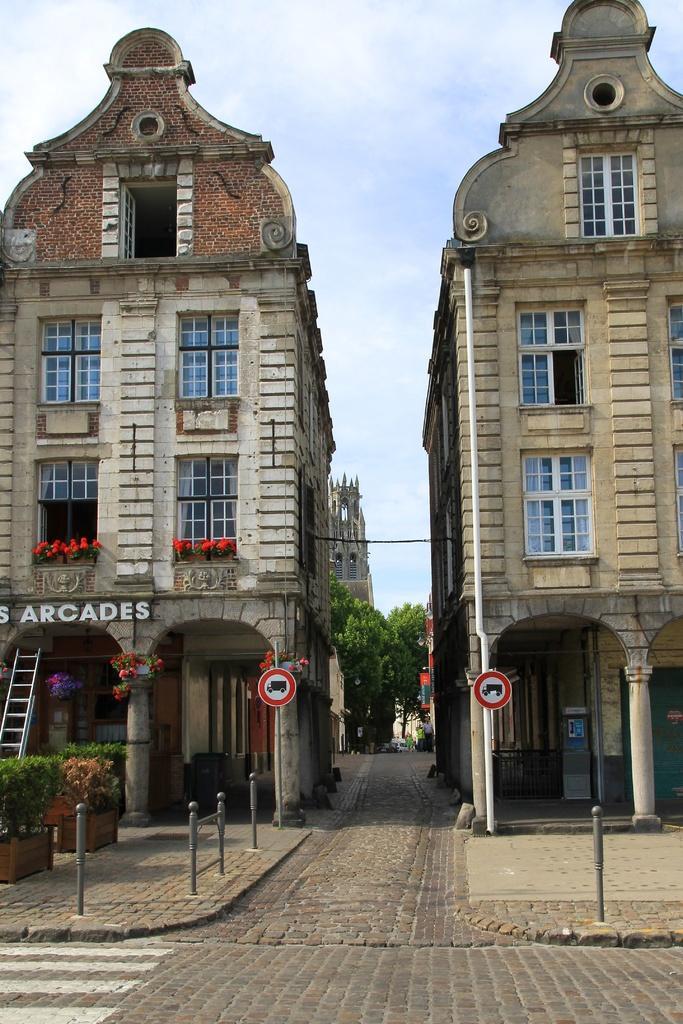Please provide a concise description of this image. In this picture I can see the path in front and on the left side of this picture, I can see few plants. In the middle of this picture, I can see few buildings, few trees and 2 sign boards. In the background I can see the clear sky. I can also see a ladder on the left side of this picture and I see something is written on the left building. 